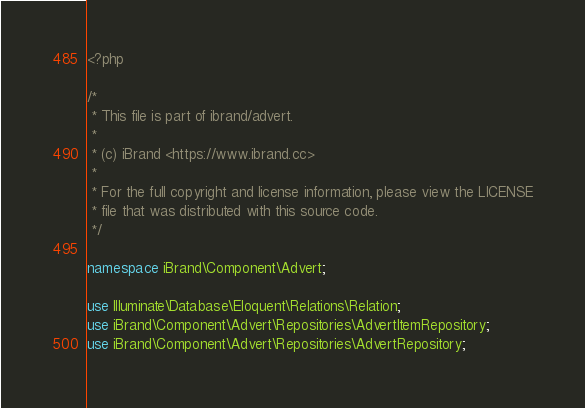Convert code to text. <code><loc_0><loc_0><loc_500><loc_500><_PHP_><?php

/*
 * This file is part of ibrand/advert.
 *
 * (c) iBrand <https://www.ibrand.cc>
 *
 * For the full copyright and license information, please view the LICENSE
 * file that was distributed with this source code.
 */

namespace iBrand\Component\Advert;

use Illuminate\Database\Eloquent\Relations\Relation;
use iBrand\Component\Advert\Repositories\AdvertItemRepository;
use iBrand\Component\Advert\Repositories\AdvertRepository;</code> 